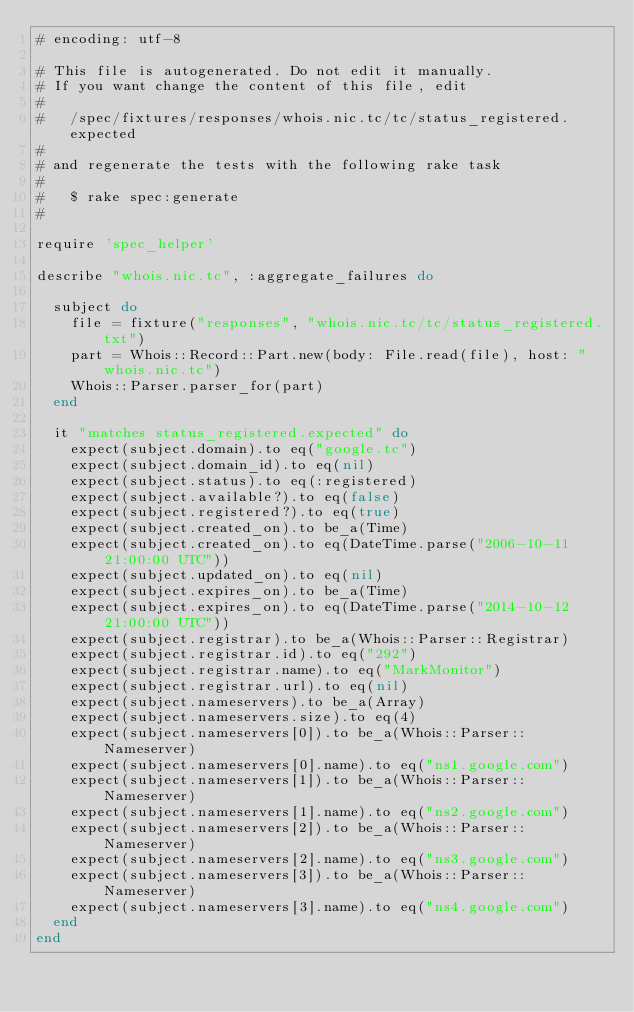<code> <loc_0><loc_0><loc_500><loc_500><_Ruby_># encoding: utf-8

# This file is autogenerated. Do not edit it manually.
# If you want change the content of this file, edit
#
#   /spec/fixtures/responses/whois.nic.tc/tc/status_registered.expected
#
# and regenerate the tests with the following rake task
#
#   $ rake spec:generate
#

require 'spec_helper'

describe "whois.nic.tc", :aggregate_failures do

  subject do
    file = fixture("responses", "whois.nic.tc/tc/status_registered.txt")
    part = Whois::Record::Part.new(body: File.read(file), host: "whois.nic.tc")
    Whois::Parser.parser_for(part)
  end

  it "matches status_registered.expected" do
    expect(subject.domain).to eq("google.tc")
    expect(subject.domain_id).to eq(nil)
    expect(subject.status).to eq(:registered)
    expect(subject.available?).to eq(false)
    expect(subject.registered?).to eq(true)
    expect(subject.created_on).to be_a(Time)
    expect(subject.created_on).to eq(DateTime.parse("2006-10-11 21:00:00 UTC"))
    expect(subject.updated_on).to eq(nil)
    expect(subject.expires_on).to be_a(Time)
    expect(subject.expires_on).to eq(DateTime.parse("2014-10-12 21:00:00 UTC"))
    expect(subject.registrar).to be_a(Whois::Parser::Registrar)
    expect(subject.registrar.id).to eq("292")
    expect(subject.registrar.name).to eq("MarkMonitor")
    expect(subject.registrar.url).to eq(nil)
    expect(subject.nameservers).to be_a(Array)
    expect(subject.nameservers.size).to eq(4)
    expect(subject.nameservers[0]).to be_a(Whois::Parser::Nameserver)
    expect(subject.nameservers[0].name).to eq("ns1.google.com")
    expect(subject.nameservers[1]).to be_a(Whois::Parser::Nameserver)
    expect(subject.nameservers[1].name).to eq("ns2.google.com")
    expect(subject.nameservers[2]).to be_a(Whois::Parser::Nameserver)
    expect(subject.nameservers[2].name).to eq("ns3.google.com")
    expect(subject.nameservers[3]).to be_a(Whois::Parser::Nameserver)
    expect(subject.nameservers[3].name).to eq("ns4.google.com")
  end
end
</code> 